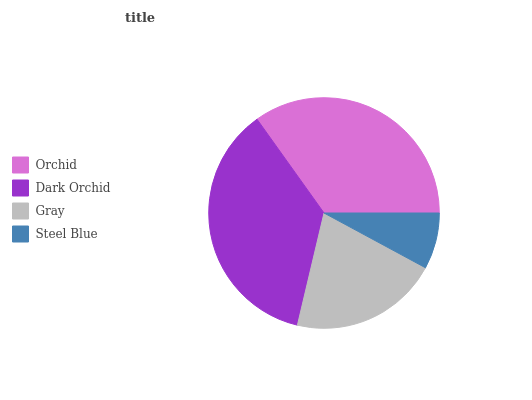Is Steel Blue the minimum?
Answer yes or no. Yes. Is Dark Orchid the maximum?
Answer yes or no. Yes. Is Gray the minimum?
Answer yes or no. No. Is Gray the maximum?
Answer yes or no. No. Is Dark Orchid greater than Gray?
Answer yes or no. Yes. Is Gray less than Dark Orchid?
Answer yes or no. Yes. Is Gray greater than Dark Orchid?
Answer yes or no. No. Is Dark Orchid less than Gray?
Answer yes or no. No. Is Orchid the high median?
Answer yes or no. Yes. Is Gray the low median?
Answer yes or no. Yes. Is Dark Orchid the high median?
Answer yes or no. No. Is Dark Orchid the low median?
Answer yes or no. No. 